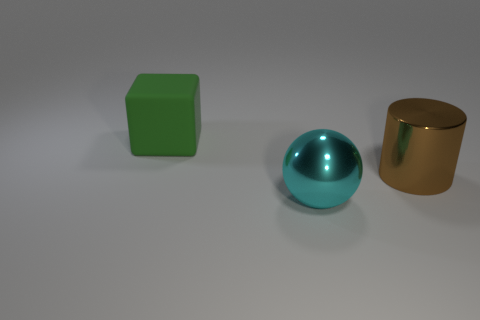Is there anything else that has the same material as the big block?
Your response must be concise. No. How many other things are there of the same material as the big cyan ball?
Your answer should be very brief. 1. Are there any metallic objects that have the same shape as the green rubber object?
Provide a succinct answer. No. What is the shape of the cyan thing that is the same size as the cylinder?
Provide a short and direct response. Sphere. How many big cylinders are the same color as the cube?
Provide a succinct answer. 0. What is the size of the shiny thing in front of the brown shiny object?
Your response must be concise. Large. How many brown spheres are the same size as the green rubber cube?
Keep it short and to the point. 0. There is a cylinder that is made of the same material as the large ball; what is its color?
Ensure brevity in your answer.  Brown. Are there fewer cyan balls that are on the right side of the large cyan metallic object than green things?
Provide a short and direct response. Yes. There is a brown object that is the same material as the big cyan object; what is its shape?
Offer a terse response. Cylinder. 